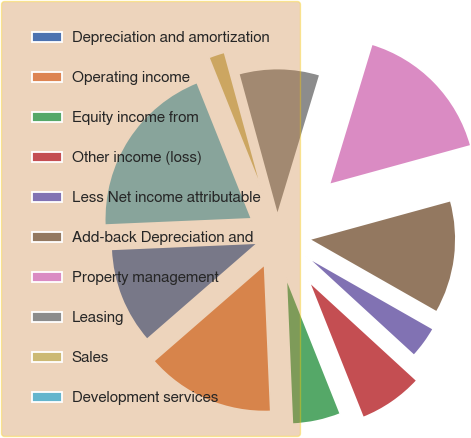Convert chart. <chart><loc_0><loc_0><loc_500><loc_500><pie_chart><fcel>Depreciation and amortization<fcel>Operating income<fcel>Equity income from<fcel>Other income (loss)<fcel>Less Net income attributable<fcel>Add-back Depreciation and<fcel>Property management<fcel>Leasing<fcel>Sales<fcel>Development services<nl><fcel>10.71%<fcel>14.28%<fcel>5.36%<fcel>7.15%<fcel>3.58%<fcel>12.5%<fcel>16.06%<fcel>8.93%<fcel>1.8%<fcel>19.63%<nl></chart> 